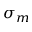Convert formula to latex. <formula><loc_0><loc_0><loc_500><loc_500>\sigma _ { m }</formula> 